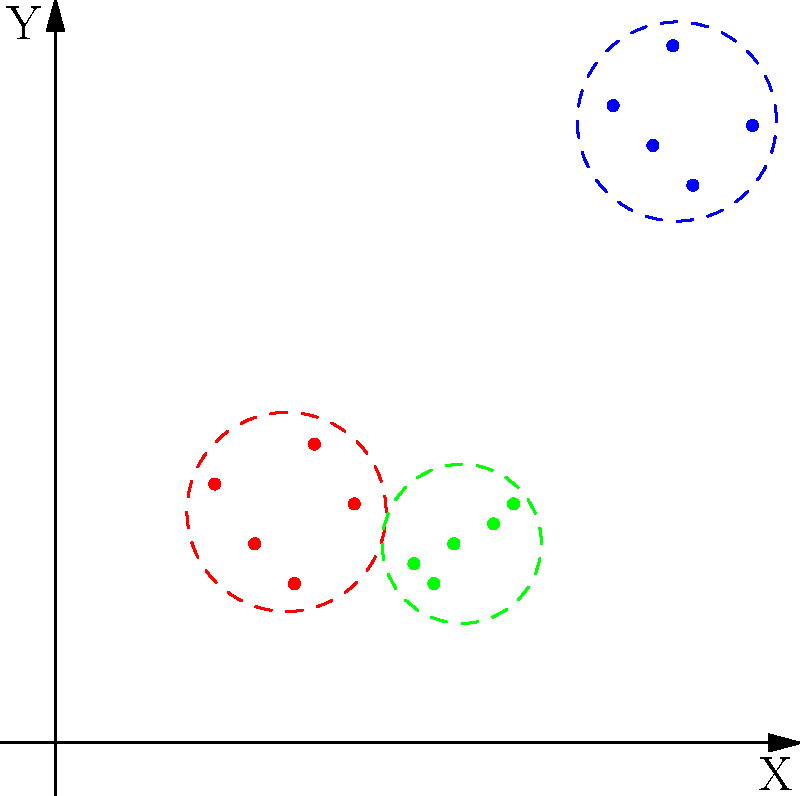As a creative writer helping a doctoral candidate, you're tasked with explaining the performance of different clustering algorithms on a 2D scatter plot. Given the image above, which clustering algorithm would likely perform better on this dataset: K-means or DBSCAN (Density-Based Spatial Clustering of Applications with Noise)? Justify your answer in terms that would be accessible to a non-technical audience. To answer this question, let's break down the characteristics of the data and the algorithms:

1. Data characteristics:
   - The scatter plot shows three distinct groups of points.
   - These groups are roughly circular in shape.
   - The groups are well-separated from each other.
   - There are no obvious outliers or noise points.

2. K-means algorithm:
   - K-means works by dividing data into a predetermined number of clusters.
   - It assumes clusters are roughly spherical and of similar size.
   - It performs well when clusters are well-separated and have a clear center.

3. DBSCAN algorithm:
   - DBSCAN groups together points that are closely packed in areas of high density.
   - It can discover clusters of arbitrary shape.
   - It's good at identifying and isolating noise or outlier points.
   - It doesn't require specifying the number of clusters beforehand.

4. Analysis:
   - The data in the plot fits well with K-means assumptions: clear, spherical clusters of similar size.
   - There are no obvious outliers or noise points that would benefit from DBSCAN's strengths.
   - The number of clusters is visually apparent, making it easy to set K for K-means.

5. Conclusion:
   K-means would likely perform better on this dataset because the clusters are well-defined, spherical, and of similar size. These characteristics align perfectly with K-means' strengths.

To explain this to a non-technical audience, you could say: "Imagine the data points as groups of people at a party. K-means is like assigning each person to the nearest group based on their location in the room. DBSCAN is more like forming groups based on how closely people are standing together. In this case, we see three clear groups standing apart from each other, making it easy for K-means to identify and separate them correctly."
Answer: K-means, due to well-defined, spherical clusters of similar size. 